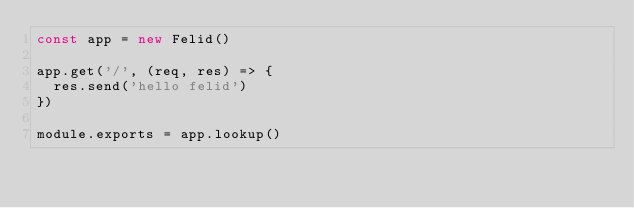<code> <loc_0><loc_0><loc_500><loc_500><_JavaScript_>const app = new Felid()

app.get('/', (req, res) => {
  res.send('hello felid')
})

module.exports = app.lookup()
</code> 